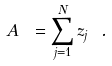<formula> <loc_0><loc_0><loc_500><loc_500>A \ = \sum _ { j = 1 } ^ { N } z _ { j } \ .</formula> 